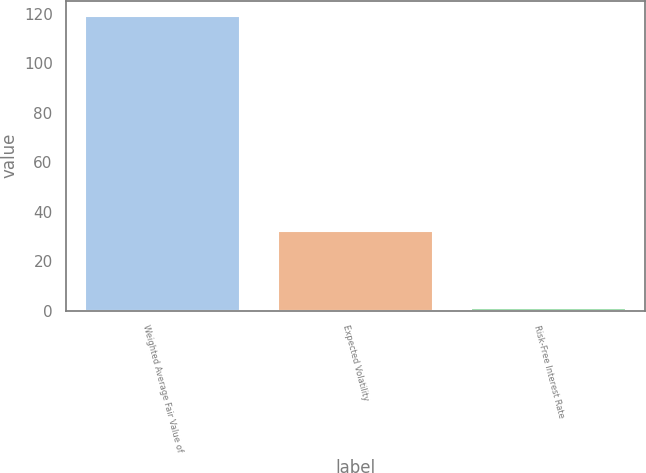<chart> <loc_0><loc_0><loc_500><loc_500><bar_chart><fcel>Weighted Average Fair Value of<fcel>Expected Volatility<fcel>Risk-Free Interest Rate<nl><fcel>119.27<fcel>32.18<fcel>1.18<nl></chart> 